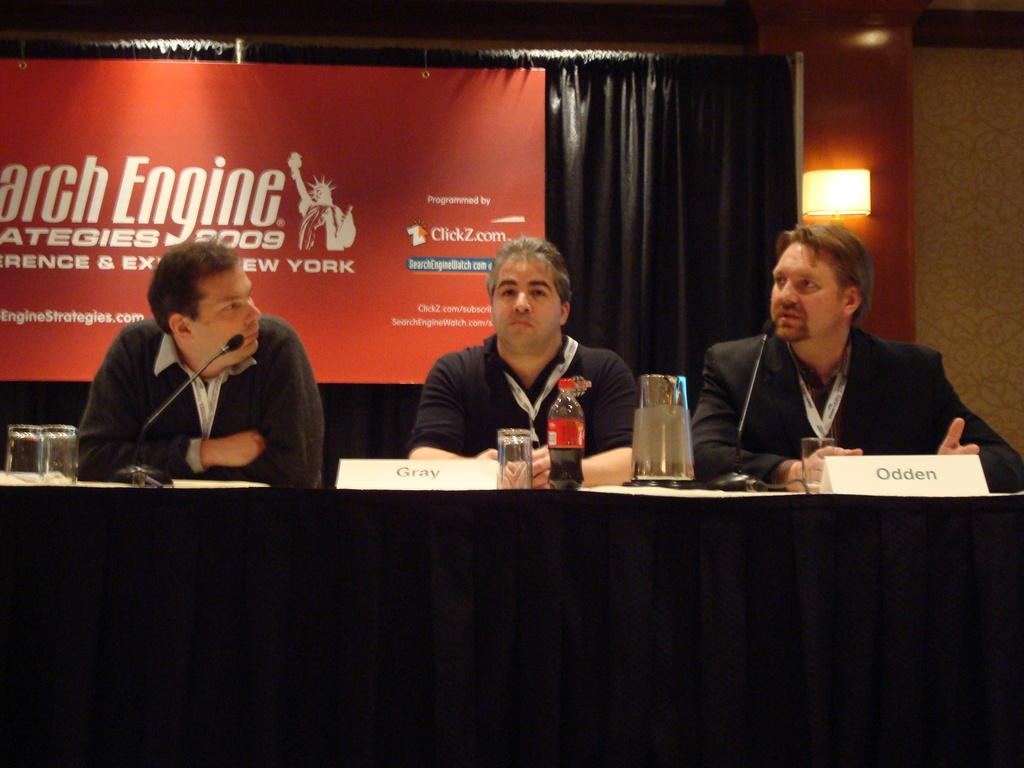<image>
Provide a brief description of the given image. 3 men at a panel about search engine strategies 